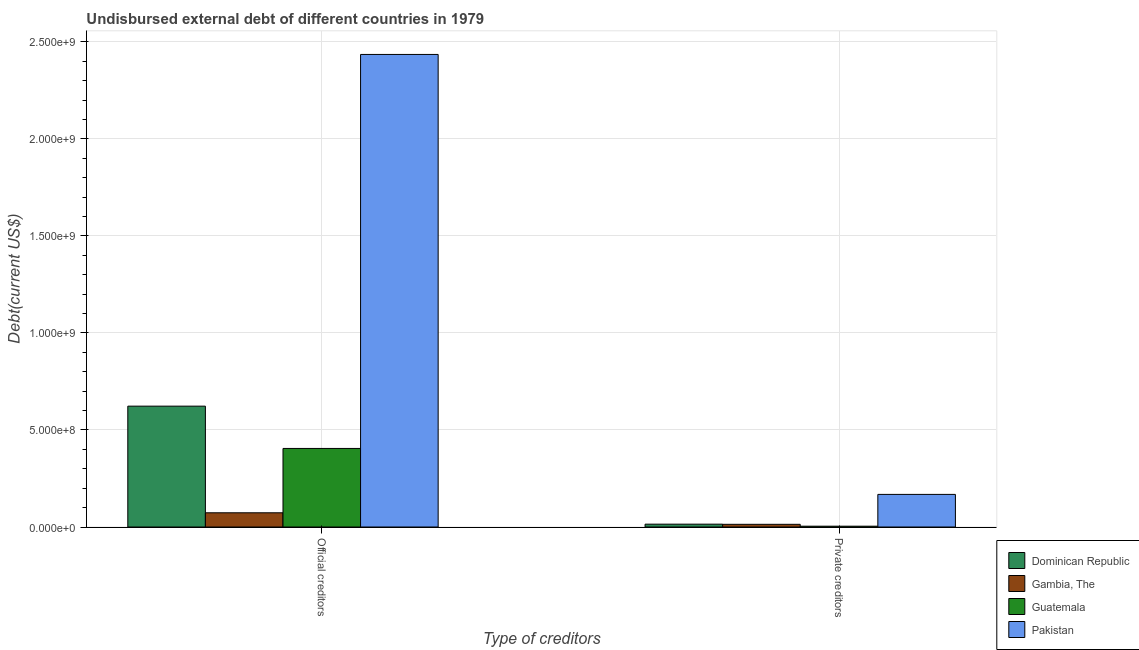How many different coloured bars are there?
Keep it short and to the point. 4. How many groups of bars are there?
Keep it short and to the point. 2. Are the number of bars on each tick of the X-axis equal?
Your response must be concise. Yes. What is the label of the 2nd group of bars from the left?
Keep it short and to the point. Private creditors. What is the undisbursed external debt of private creditors in Pakistan?
Make the answer very short. 1.68e+08. Across all countries, what is the maximum undisbursed external debt of private creditors?
Make the answer very short. 1.68e+08. Across all countries, what is the minimum undisbursed external debt of official creditors?
Make the answer very short. 7.33e+07. In which country was the undisbursed external debt of private creditors maximum?
Keep it short and to the point. Pakistan. In which country was the undisbursed external debt of official creditors minimum?
Make the answer very short. Gambia, The. What is the total undisbursed external debt of official creditors in the graph?
Ensure brevity in your answer.  3.54e+09. What is the difference between the undisbursed external debt of private creditors in Pakistan and that in Dominican Republic?
Offer a terse response. 1.53e+08. What is the difference between the undisbursed external debt of private creditors in Dominican Republic and the undisbursed external debt of official creditors in Gambia, The?
Keep it short and to the point. -5.86e+07. What is the average undisbursed external debt of official creditors per country?
Offer a very short reply. 8.84e+08. What is the difference between the undisbursed external debt of official creditors and undisbursed external debt of private creditors in Pakistan?
Your answer should be very brief. 2.27e+09. In how many countries, is the undisbursed external debt of private creditors greater than 900000000 US$?
Keep it short and to the point. 0. What is the ratio of the undisbursed external debt of private creditors in Dominican Republic to that in Pakistan?
Your answer should be compact. 0.09. What does the 3rd bar from the left in Private creditors represents?
Your answer should be compact. Guatemala. What does the 3rd bar from the right in Private creditors represents?
Offer a terse response. Gambia, The. How many bars are there?
Make the answer very short. 8. Are all the bars in the graph horizontal?
Your answer should be compact. No. What is the difference between two consecutive major ticks on the Y-axis?
Give a very brief answer. 5.00e+08. Does the graph contain any zero values?
Your response must be concise. No. Does the graph contain grids?
Your answer should be very brief. Yes. Where does the legend appear in the graph?
Your response must be concise. Bottom right. What is the title of the graph?
Keep it short and to the point. Undisbursed external debt of different countries in 1979. Does "Botswana" appear as one of the legend labels in the graph?
Keep it short and to the point. No. What is the label or title of the X-axis?
Provide a short and direct response. Type of creditors. What is the label or title of the Y-axis?
Keep it short and to the point. Debt(current US$). What is the Debt(current US$) in Dominican Republic in Official creditors?
Provide a short and direct response. 6.23e+08. What is the Debt(current US$) in Gambia, The in Official creditors?
Ensure brevity in your answer.  7.33e+07. What is the Debt(current US$) in Guatemala in Official creditors?
Keep it short and to the point. 4.05e+08. What is the Debt(current US$) of Pakistan in Official creditors?
Make the answer very short. 2.43e+09. What is the Debt(current US$) in Dominican Republic in Private creditors?
Make the answer very short. 1.47e+07. What is the Debt(current US$) in Gambia, The in Private creditors?
Make the answer very short. 1.39e+07. What is the Debt(current US$) in Guatemala in Private creditors?
Your answer should be very brief. 4.18e+06. What is the Debt(current US$) of Pakistan in Private creditors?
Give a very brief answer. 1.68e+08. Across all Type of creditors, what is the maximum Debt(current US$) in Dominican Republic?
Offer a terse response. 6.23e+08. Across all Type of creditors, what is the maximum Debt(current US$) of Gambia, The?
Provide a short and direct response. 7.33e+07. Across all Type of creditors, what is the maximum Debt(current US$) of Guatemala?
Your answer should be compact. 4.05e+08. Across all Type of creditors, what is the maximum Debt(current US$) of Pakistan?
Provide a short and direct response. 2.43e+09. Across all Type of creditors, what is the minimum Debt(current US$) of Dominican Republic?
Offer a very short reply. 1.47e+07. Across all Type of creditors, what is the minimum Debt(current US$) of Gambia, The?
Offer a very short reply. 1.39e+07. Across all Type of creditors, what is the minimum Debt(current US$) of Guatemala?
Give a very brief answer. 4.18e+06. Across all Type of creditors, what is the minimum Debt(current US$) in Pakistan?
Provide a succinct answer. 1.68e+08. What is the total Debt(current US$) of Dominican Republic in the graph?
Ensure brevity in your answer.  6.37e+08. What is the total Debt(current US$) of Gambia, The in the graph?
Offer a very short reply. 8.71e+07. What is the total Debt(current US$) in Guatemala in the graph?
Provide a succinct answer. 4.09e+08. What is the total Debt(current US$) of Pakistan in the graph?
Make the answer very short. 2.60e+09. What is the difference between the Debt(current US$) in Dominican Republic in Official creditors and that in Private creditors?
Give a very brief answer. 6.08e+08. What is the difference between the Debt(current US$) in Gambia, The in Official creditors and that in Private creditors?
Provide a short and direct response. 5.94e+07. What is the difference between the Debt(current US$) of Guatemala in Official creditors and that in Private creditors?
Keep it short and to the point. 4.01e+08. What is the difference between the Debt(current US$) in Pakistan in Official creditors and that in Private creditors?
Offer a very short reply. 2.27e+09. What is the difference between the Debt(current US$) of Dominican Republic in Official creditors and the Debt(current US$) of Gambia, The in Private creditors?
Make the answer very short. 6.09e+08. What is the difference between the Debt(current US$) in Dominican Republic in Official creditors and the Debt(current US$) in Guatemala in Private creditors?
Ensure brevity in your answer.  6.19e+08. What is the difference between the Debt(current US$) in Dominican Republic in Official creditors and the Debt(current US$) in Pakistan in Private creditors?
Your answer should be very brief. 4.55e+08. What is the difference between the Debt(current US$) in Gambia, The in Official creditors and the Debt(current US$) in Guatemala in Private creditors?
Keep it short and to the point. 6.91e+07. What is the difference between the Debt(current US$) in Gambia, The in Official creditors and the Debt(current US$) in Pakistan in Private creditors?
Keep it short and to the point. -9.48e+07. What is the difference between the Debt(current US$) of Guatemala in Official creditors and the Debt(current US$) of Pakistan in Private creditors?
Offer a terse response. 2.37e+08. What is the average Debt(current US$) in Dominican Republic per Type of creditors?
Your response must be concise. 3.19e+08. What is the average Debt(current US$) of Gambia, The per Type of creditors?
Ensure brevity in your answer.  4.36e+07. What is the average Debt(current US$) of Guatemala per Type of creditors?
Your answer should be compact. 2.04e+08. What is the average Debt(current US$) of Pakistan per Type of creditors?
Your answer should be compact. 1.30e+09. What is the difference between the Debt(current US$) in Dominican Republic and Debt(current US$) in Gambia, The in Official creditors?
Provide a short and direct response. 5.50e+08. What is the difference between the Debt(current US$) in Dominican Republic and Debt(current US$) in Guatemala in Official creditors?
Provide a succinct answer. 2.18e+08. What is the difference between the Debt(current US$) in Dominican Republic and Debt(current US$) in Pakistan in Official creditors?
Keep it short and to the point. -1.81e+09. What is the difference between the Debt(current US$) in Gambia, The and Debt(current US$) in Guatemala in Official creditors?
Provide a short and direct response. -3.32e+08. What is the difference between the Debt(current US$) of Gambia, The and Debt(current US$) of Pakistan in Official creditors?
Your answer should be compact. -2.36e+09. What is the difference between the Debt(current US$) of Guatemala and Debt(current US$) of Pakistan in Official creditors?
Ensure brevity in your answer.  -2.03e+09. What is the difference between the Debt(current US$) in Dominican Republic and Debt(current US$) in Gambia, The in Private creditors?
Your answer should be very brief. 8.21e+05. What is the difference between the Debt(current US$) in Dominican Republic and Debt(current US$) in Guatemala in Private creditors?
Provide a succinct answer. 1.05e+07. What is the difference between the Debt(current US$) in Dominican Republic and Debt(current US$) in Pakistan in Private creditors?
Offer a very short reply. -1.53e+08. What is the difference between the Debt(current US$) in Gambia, The and Debt(current US$) in Guatemala in Private creditors?
Offer a very short reply. 9.69e+06. What is the difference between the Debt(current US$) of Gambia, The and Debt(current US$) of Pakistan in Private creditors?
Give a very brief answer. -1.54e+08. What is the difference between the Debt(current US$) in Guatemala and Debt(current US$) in Pakistan in Private creditors?
Your answer should be very brief. -1.64e+08. What is the ratio of the Debt(current US$) of Dominican Republic in Official creditors to that in Private creditors?
Give a very brief answer. 42.41. What is the ratio of the Debt(current US$) of Gambia, The in Official creditors to that in Private creditors?
Your answer should be compact. 5.29. What is the ratio of the Debt(current US$) in Guatemala in Official creditors to that in Private creditors?
Ensure brevity in your answer.  96.96. What is the ratio of the Debt(current US$) in Pakistan in Official creditors to that in Private creditors?
Your response must be concise. 14.49. What is the difference between the highest and the second highest Debt(current US$) of Dominican Republic?
Keep it short and to the point. 6.08e+08. What is the difference between the highest and the second highest Debt(current US$) of Gambia, The?
Your answer should be compact. 5.94e+07. What is the difference between the highest and the second highest Debt(current US$) of Guatemala?
Offer a very short reply. 4.01e+08. What is the difference between the highest and the second highest Debt(current US$) in Pakistan?
Provide a short and direct response. 2.27e+09. What is the difference between the highest and the lowest Debt(current US$) of Dominican Republic?
Your answer should be very brief. 6.08e+08. What is the difference between the highest and the lowest Debt(current US$) in Gambia, The?
Offer a very short reply. 5.94e+07. What is the difference between the highest and the lowest Debt(current US$) of Guatemala?
Your answer should be compact. 4.01e+08. What is the difference between the highest and the lowest Debt(current US$) in Pakistan?
Your answer should be compact. 2.27e+09. 